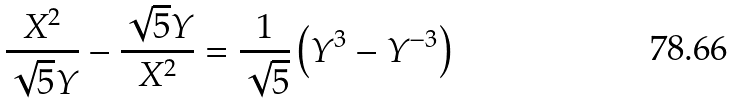<formula> <loc_0><loc_0><loc_500><loc_500>\frac { X ^ { 2 } } { \sqrt { 5 } Y } - \frac { \sqrt { 5 } Y } { X ^ { 2 } } = \frac { 1 } { \sqrt { 5 } } \left ( Y ^ { 3 } - Y ^ { - 3 } \right )</formula> 